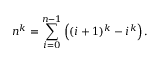Convert formula to latex. <formula><loc_0><loc_0><loc_500><loc_500>n ^ { k } = \sum _ { i = 0 } ^ { n - 1 } \left ( ( i + 1 ) ^ { k } - i ^ { k } \right ) .</formula> 